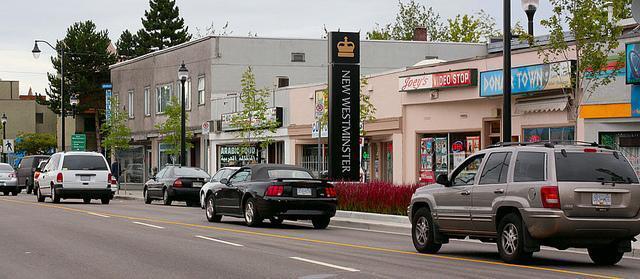How many cars are in the picture?
Give a very brief answer. 4. 